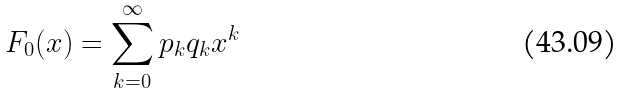<formula> <loc_0><loc_0><loc_500><loc_500>F _ { 0 } ( x ) = \sum _ { k = 0 } ^ { \infty } p _ { k } q _ { k } x ^ { k }</formula> 